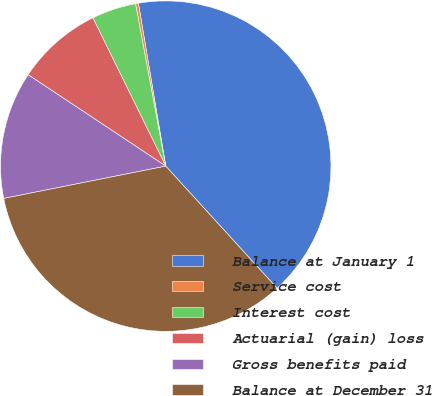Convert chart. <chart><loc_0><loc_0><loc_500><loc_500><pie_chart><fcel>Balance at January 1<fcel>Service cost<fcel>Interest cost<fcel>Actuarial (gain) loss<fcel>Gross benefits paid<fcel>Balance at December 31<nl><fcel>40.88%<fcel>0.28%<fcel>4.34%<fcel>8.4%<fcel>12.46%<fcel>33.63%<nl></chart> 